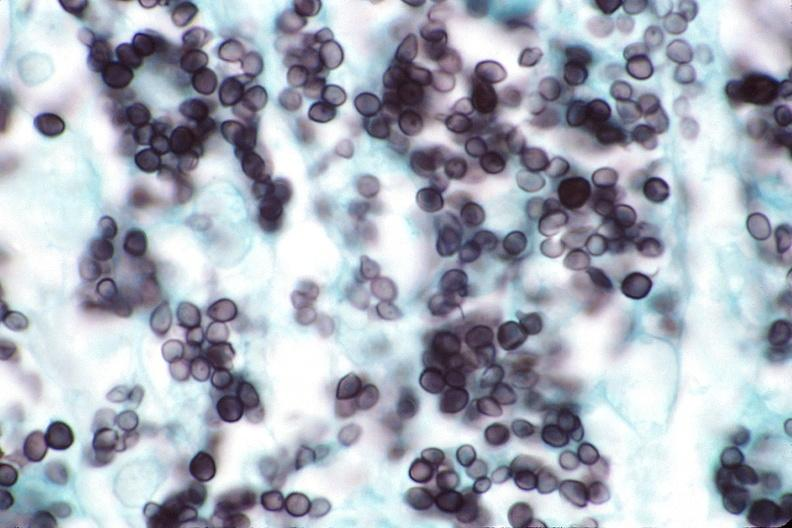does cranial artery show lung, histoplasma pneumonia?
Answer the question using a single word or phrase. No 